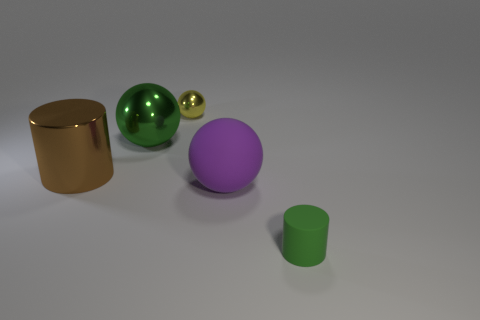What is the size of the green object that is on the right side of the yellow metal sphere?
Provide a short and direct response. Small. Are there any small green matte things behind the small ball behind the big matte thing?
Offer a terse response. No. Does the ball that is on the left side of the yellow metal ball have the same color as the small object that is in front of the big green metallic thing?
Ensure brevity in your answer.  Yes. What is the color of the large metallic cylinder?
Your response must be concise. Brown. Is there anything else that has the same color as the tiny rubber object?
Offer a very short reply. Yes. There is a big object that is right of the large brown cylinder and to the left of the small yellow shiny thing; what is its color?
Your answer should be compact. Green. Does the green thing behind the brown metal cylinder have the same size as the big brown metal object?
Give a very brief answer. Yes. Is the number of brown cylinders on the left side of the tiny green rubber object greater than the number of big green matte objects?
Your response must be concise. Yes. Do the brown object and the small metal object have the same shape?
Your answer should be compact. No. What size is the metallic cylinder?
Offer a very short reply. Large. 